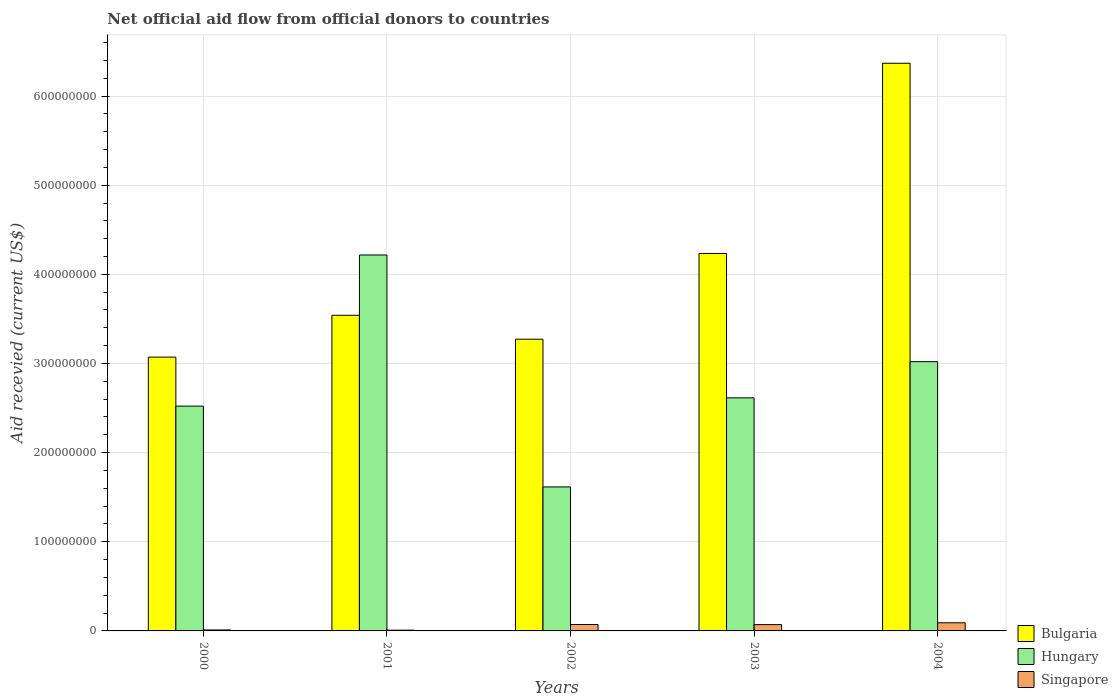How many different coloured bars are there?
Keep it short and to the point. 3. Are the number of bars per tick equal to the number of legend labels?
Your answer should be compact. Yes. What is the label of the 3rd group of bars from the left?
Your answer should be compact. 2002. In how many cases, is the number of bars for a given year not equal to the number of legend labels?
Your answer should be very brief. 0. What is the total aid received in Hungary in 2002?
Ensure brevity in your answer.  1.62e+08. Across all years, what is the maximum total aid received in Singapore?
Your answer should be compact. 9.14e+06. Across all years, what is the minimum total aid received in Bulgaria?
Your answer should be very brief. 3.07e+08. In which year was the total aid received in Hungary maximum?
Give a very brief answer. 2001. What is the total total aid received in Singapore in the graph?
Offer a terse response. 2.53e+07. What is the difference between the total aid received in Hungary in 2002 and that in 2003?
Your answer should be compact. -9.99e+07. What is the difference between the total aid received in Bulgaria in 2001 and the total aid received in Singapore in 2004?
Keep it short and to the point. 3.45e+08. What is the average total aid received in Hungary per year?
Ensure brevity in your answer.  2.80e+08. In the year 2002, what is the difference between the total aid received in Hungary and total aid received in Bulgaria?
Ensure brevity in your answer.  -1.66e+08. What is the ratio of the total aid received in Bulgaria in 2002 to that in 2004?
Give a very brief answer. 0.51. Is the total aid received in Hungary in 2002 less than that in 2003?
Provide a short and direct response. Yes. What is the difference between the highest and the second highest total aid received in Hungary?
Your answer should be very brief. 1.20e+08. What is the difference between the highest and the lowest total aid received in Singapore?
Your answer should be very brief. 8.29e+06. What does the 1st bar from the left in 2000 represents?
Keep it short and to the point. Bulgaria. What does the 2nd bar from the right in 2001 represents?
Offer a very short reply. Hungary. Is it the case that in every year, the sum of the total aid received in Bulgaria and total aid received in Hungary is greater than the total aid received in Singapore?
Make the answer very short. Yes. Are all the bars in the graph horizontal?
Provide a succinct answer. No. What is the difference between two consecutive major ticks on the Y-axis?
Give a very brief answer. 1.00e+08. Does the graph contain any zero values?
Give a very brief answer. No. Where does the legend appear in the graph?
Offer a terse response. Bottom right. What is the title of the graph?
Your answer should be very brief. Net official aid flow from official donors to countries. What is the label or title of the X-axis?
Provide a succinct answer. Years. What is the label or title of the Y-axis?
Provide a succinct answer. Aid recevied (current US$). What is the Aid recevied (current US$) in Bulgaria in 2000?
Provide a short and direct response. 3.07e+08. What is the Aid recevied (current US$) of Hungary in 2000?
Make the answer very short. 2.52e+08. What is the Aid recevied (current US$) of Singapore in 2000?
Make the answer very short. 1.09e+06. What is the Aid recevied (current US$) of Bulgaria in 2001?
Keep it short and to the point. 3.54e+08. What is the Aid recevied (current US$) of Hungary in 2001?
Your answer should be very brief. 4.22e+08. What is the Aid recevied (current US$) of Singapore in 2001?
Give a very brief answer. 8.50e+05. What is the Aid recevied (current US$) in Bulgaria in 2002?
Your answer should be very brief. 3.27e+08. What is the Aid recevied (current US$) of Hungary in 2002?
Make the answer very short. 1.62e+08. What is the Aid recevied (current US$) in Singapore in 2002?
Make the answer very short. 7.19e+06. What is the Aid recevied (current US$) of Bulgaria in 2003?
Keep it short and to the point. 4.23e+08. What is the Aid recevied (current US$) of Hungary in 2003?
Provide a short and direct response. 2.61e+08. What is the Aid recevied (current US$) of Singapore in 2003?
Your response must be concise. 7.07e+06. What is the Aid recevied (current US$) in Bulgaria in 2004?
Provide a short and direct response. 6.37e+08. What is the Aid recevied (current US$) of Hungary in 2004?
Your answer should be compact. 3.02e+08. What is the Aid recevied (current US$) of Singapore in 2004?
Make the answer very short. 9.14e+06. Across all years, what is the maximum Aid recevied (current US$) of Bulgaria?
Provide a short and direct response. 6.37e+08. Across all years, what is the maximum Aid recevied (current US$) in Hungary?
Your answer should be very brief. 4.22e+08. Across all years, what is the maximum Aid recevied (current US$) in Singapore?
Ensure brevity in your answer.  9.14e+06. Across all years, what is the minimum Aid recevied (current US$) of Bulgaria?
Give a very brief answer. 3.07e+08. Across all years, what is the minimum Aid recevied (current US$) of Hungary?
Keep it short and to the point. 1.62e+08. Across all years, what is the minimum Aid recevied (current US$) of Singapore?
Make the answer very short. 8.50e+05. What is the total Aid recevied (current US$) of Bulgaria in the graph?
Offer a very short reply. 2.05e+09. What is the total Aid recevied (current US$) in Hungary in the graph?
Provide a short and direct response. 1.40e+09. What is the total Aid recevied (current US$) of Singapore in the graph?
Offer a very short reply. 2.53e+07. What is the difference between the Aid recevied (current US$) of Bulgaria in 2000 and that in 2001?
Give a very brief answer. -4.69e+07. What is the difference between the Aid recevied (current US$) of Hungary in 2000 and that in 2001?
Ensure brevity in your answer.  -1.70e+08. What is the difference between the Aid recevied (current US$) of Singapore in 2000 and that in 2001?
Your response must be concise. 2.40e+05. What is the difference between the Aid recevied (current US$) of Bulgaria in 2000 and that in 2002?
Ensure brevity in your answer.  -2.01e+07. What is the difference between the Aid recevied (current US$) in Hungary in 2000 and that in 2002?
Your answer should be compact. 9.06e+07. What is the difference between the Aid recevied (current US$) of Singapore in 2000 and that in 2002?
Offer a terse response. -6.10e+06. What is the difference between the Aid recevied (current US$) in Bulgaria in 2000 and that in 2003?
Your answer should be very brief. -1.16e+08. What is the difference between the Aid recevied (current US$) of Hungary in 2000 and that in 2003?
Provide a succinct answer. -9.28e+06. What is the difference between the Aid recevied (current US$) of Singapore in 2000 and that in 2003?
Provide a short and direct response. -5.98e+06. What is the difference between the Aid recevied (current US$) in Bulgaria in 2000 and that in 2004?
Give a very brief answer. -3.30e+08. What is the difference between the Aid recevied (current US$) in Hungary in 2000 and that in 2004?
Ensure brevity in your answer.  -4.98e+07. What is the difference between the Aid recevied (current US$) in Singapore in 2000 and that in 2004?
Offer a terse response. -8.05e+06. What is the difference between the Aid recevied (current US$) of Bulgaria in 2001 and that in 2002?
Offer a terse response. 2.68e+07. What is the difference between the Aid recevied (current US$) of Hungary in 2001 and that in 2002?
Provide a succinct answer. 2.60e+08. What is the difference between the Aid recevied (current US$) in Singapore in 2001 and that in 2002?
Your response must be concise. -6.34e+06. What is the difference between the Aid recevied (current US$) in Bulgaria in 2001 and that in 2003?
Give a very brief answer. -6.94e+07. What is the difference between the Aid recevied (current US$) in Hungary in 2001 and that in 2003?
Your answer should be compact. 1.60e+08. What is the difference between the Aid recevied (current US$) in Singapore in 2001 and that in 2003?
Your answer should be compact. -6.22e+06. What is the difference between the Aid recevied (current US$) in Bulgaria in 2001 and that in 2004?
Ensure brevity in your answer.  -2.83e+08. What is the difference between the Aid recevied (current US$) of Hungary in 2001 and that in 2004?
Provide a short and direct response. 1.20e+08. What is the difference between the Aid recevied (current US$) of Singapore in 2001 and that in 2004?
Your answer should be compact. -8.29e+06. What is the difference between the Aid recevied (current US$) of Bulgaria in 2002 and that in 2003?
Your answer should be compact. -9.62e+07. What is the difference between the Aid recevied (current US$) in Hungary in 2002 and that in 2003?
Keep it short and to the point. -9.99e+07. What is the difference between the Aid recevied (current US$) of Bulgaria in 2002 and that in 2004?
Provide a succinct answer. -3.10e+08. What is the difference between the Aid recevied (current US$) in Hungary in 2002 and that in 2004?
Your answer should be compact. -1.40e+08. What is the difference between the Aid recevied (current US$) of Singapore in 2002 and that in 2004?
Give a very brief answer. -1.95e+06. What is the difference between the Aid recevied (current US$) of Bulgaria in 2003 and that in 2004?
Provide a short and direct response. -2.13e+08. What is the difference between the Aid recevied (current US$) of Hungary in 2003 and that in 2004?
Make the answer very short. -4.06e+07. What is the difference between the Aid recevied (current US$) of Singapore in 2003 and that in 2004?
Offer a terse response. -2.07e+06. What is the difference between the Aid recevied (current US$) in Bulgaria in 2000 and the Aid recevied (current US$) in Hungary in 2001?
Offer a terse response. -1.15e+08. What is the difference between the Aid recevied (current US$) of Bulgaria in 2000 and the Aid recevied (current US$) of Singapore in 2001?
Give a very brief answer. 3.06e+08. What is the difference between the Aid recevied (current US$) in Hungary in 2000 and the Aid recevied (current US$) in Singapore in 2001?
Your response must be concise. 2.51e+08. What is the difference between the Aid recevied (current US$) of Bulgaria in 2000 and the Aid recevied (current US$) of Hungary in 2002?
Your response must be concise. 1.46e+08. What is the difference between the Aid recevied (current US$) of Bulgaria in 2000 and the Aid recevied (current US$) of Singapore in 2002?
Provide a succinct answer. 3.00e+08. What is the difference between the Aid recevied (current US$) in Hungary in 2000 and the Aid recevied (current US$) in Singapore in 2002?
Offer a terse response. 2.45e+08. What is the difference between the Aid recevied (current US$) in Bulgaria in 2000 and the Aid recevied (current US$) in Hungary in 2003?
Ensure brevity in your answer.  4.57e+07. What is the difference between the Aid recevied (current US$) in Bulgaria in 2000 and the Aid recevied (current US$) in Singapore in 2003?
Your answer should be compact. 3.00e+08. What is the difference between the Aid recevied (current US$) of Hungary in 2000 and the Aid recevied (current US$) of Singapore in 2003?
Make the answer very short. 2.45e+08. What is the difference between the Aid recevied (current US$) in Bulgaria in 2000 and the Aid recevied (current US$) in Hungary in 2004?
Offer a very short reply. 5.13e+06. What is the difference between the Aid recevied (current US$) in Bulgaria in 2000 and the Aid recevied (current US$) in Singapore in 2004?
Your response must be concise. 2.98e+08. What is the difference between the Aid recevied (current US$) of Hungary in 2000 and the Aid recevied (current US$) of Singapore in 2004?
Your response must be concise. 2.43e+08. What is the difference between the Aid recevied (current US$) in Bulgaria in 2001 and the Aid recevied (current US$) in Hungary in 2002?
Provide a succinct answer. 1.93e+08. What is the difference between the Aid recevied (current US$) in Bulgaria in 2001 and the Aid recevied (current US$) in Singapore in 2002?
Give a very brief answer. 3.47e+08. What is the difference between the Aid recevied (current US$) in Hungary in 2001 and the Aid recevied (current US$) in Singapore in 2002?
Give a very brief answer. 4.14e+08. What is the difference between the Aid recevied (current US$) of Bulgaria in 2001 and the Aid recevied (current US$) of Hungary in 2003?
Your answer should be compact. 9.26e+07. What is the difference between the Aid recevied (current US$) of Bulgaria in 2001 and the Aid recevied (current US$) of Singapore in 2003?
Provide a short and direct response. 3.47e+08. What is the difference between the Aid recevied (current US$) in Hungary in 2001 and the Aid recevied (current US$) in Singapore in 2003?
Provide a short and direct response. 4.15e+08. What is the difference between the Aid recevied (current US$) in Bulgaria in 2001 and the Aid recevied (current US$) in Hungary in 2004?
Offer a terse response. 5.20e+07. What is the difference between the Aid recevied (current US$) in Bulgaria in 2001 and the Aid recevied (current US$) in Singapore in 2004?
Provide a succinct answer. 3.45e+08. What is the difference between the Aid recevied (current US$) in Hungary in 2001 and the Aid recevied (current US$) in Singapore in 2004?
Keep it short and to the point. 4.13e+08. What is the difference between the Aid recevied (current US$) of Bulgaria in 2002 and the Aid recevied (current US$) of Hungary in 2003?
Make the answer very short. 6.58e+07. What is the difference between the Aid recevied (current US$) of Bulgaria in 2002 and the Aid recevied (current US$) of Singapore in 2003?
Make the answer very short. 3.20e+08. What is the difference between the Aid recevied (current US$) in Hungary in 2002 and the Aid recevied (current US$) in Singapore in 2003?
Your answer should be very brief. 1.54e+08. What is the difference between the Aid recevied (current US$) of Bulgaria in 2002 and the Aid recevied (current US$) of Hungary in 2004?
Offer a very short reply. 2.52e+07. What is the difference between the Aid recevied (current US$) of Bulgaria in 2002 and the Aid recevied (current US$) of Singapore in 2004?
Make the answer very short. 3.18e+08. What is the difference between the Aid recevied (current US$) of Hungary in 2002 and the Aid recevied (current US$) of Singapore in 2004?
Provide a short and direct response. 1.52e+08. What is the difference between the Aid recevied (current US$) of Bulgaria in 2003 and the Aid recevied (current US$) of Hungary in 2004?
Make the answer very short. 1.21e+08. What is the difference between the Aid recevied (current US$) in Bulgaria in 2003 and the Aid recevied (current US$) in Singapore in 2004?
Make the answer very short. 4.14e+08. What is the difference between the Aid recevied (current US$) in Hungary in 2003 and the Aid recevied (current US$) in Singapore in 2004?
Your answer should be very brief. 2.52e+08. What is the average Aid recevied (current US$) in Bulgaria per year?
Keep it short and to the point. 4.10e+08. What is the average Aid recevied (current US$) in Hungary per year?
Keep it short and to the point. 2.80e+08. What is the average Aid recevied (current US$) in Singapore per year?
Ensure brevity in your answer.  5.07e+06. In the year 2000, what is the difference between the Aid recevied (current US$) of Bulgaria and Aid recevied (current US$) of Hungary?
Your response must be concise. 5.50e+07. In the year 2000, what is the difference between the Aid recevied (current US$) in Bulgaria and Aid recevied (current US$) in Singapore?
Provide a succinct answer. 3.06e+08. In the year 2000, what is the difference between the Aid recevied (current US$) of Hungary and Aid recevied (current US$) of Singapore?
Provide a short and direct response. 2.51e+08. In the year 2001, what is the difference between the Aid recevied (current US$) in Bulgaria and Aid recevied (current US$) in Hungary?
Provide a short and direct response. -6.76e+07. In the year 2001, what is the difference between the Aid recevied (current US$) of Bulgaria and Aid recevied (current US$) of Singapore?
Give a very brief answer. 3.53e+08. In the year 2001, what is the difference between the Aid recevied (current US$) in Hungary and Aid recevied (current US$) in Singapore?
Make the answer very short. 4.21e+08. In the year 2002, what is the difference between the Aid recevied (current US$) in Bulgaria and Aid recevied (current US$) in Hungary?
Ensure brevity in your answer.  1.66e+08. In the year 2002, what is the difference between the Aid recevied (current US$) of Bulgaria and Aid recevied (current US$) of Singapore?
Your answer should be compact. 3.20e+08. In the year 2002, what is the difference between the Aid recevied (current US$) of Hungary and Aid recevied (current US$) of Singapore?
Give a very brief answer. 1.54e+08. In the year 2003, what is the difference between the Aid recevied (current US$) in Bulgaria and Aid recevied (current US$) in Hungary?
Ensure brevity in your answer.  1.62e+08. In the year 2003, what is the difference between the Aid recevied (current US$) in Bulgaria and Aid recevied (current US$) in Singapore?
Ensure brevity in your answer.  4.16e+08. In the year 2003, what is the difference between the Aid recevied (current US$) in Hungary and Aid recevied (current US$) in Singapore?
Make the answer very short. 2.54e+08. In the year 2004, what is the difference between the Aid recevied (current US$) in Bulgaria and Aid recevied (current US$) in Hungary?
Ensure brevity in your answer.  3.35e+08. In the year 2004, what is the difference between the Aid recevied (current US$) of Bulgaria and Aid recevied (current US$) of Singapore?
Provide a succinct answer. 6.28e+08. In the year 2004, what is the difference between the Aid recevied (current US$) in Hungary and Aid recevied (current US$) in Singapore?
Your answer should be compact. 2.93e+08. What is the ratio of the Aid recevied (current US$) of Bulgaria in 2000 to that in 2001?
Make the answer very short. 0.87. What is the ratio of the Aid recevied (current US$) of Hungary in 2000 to that in 2001?
Ensure brevity in your answer.  0.6. What is the ratio of the Aid recevied (current US$) of Singapore in 2000 to that in 2001?
Make the answer very short. 1.28. What is the ratio of the Aid recevied (current US$) of Bulgaria in 2000 to that in 2002?
Give a very brief answer. 0.94. What is the ratio of the Aid recevied (current US$) of Hungary in 2000 to that in 2002?
Give a very brief answer. 1.56. What is the ratio of the Aid recevied (current US$) of Singapore in 2000 to that in 2002?
Your answer should be very brief. 0.15. What is the ratio of the Aid recevied (current US$) in Bulgaria in 2000 to that in 2003?
Offer a very short reply. 0.73. What is the ratio of the Aid recevied (current US$) of Hungary in 2000 to that in 2003?
Provide a succinct answer. 0.96. What is the ratio of the Aid recevied (current US$) of Singapore in 2000 to that in 2003?
Make the answer very short. 0.15. What is the ratio of the Aid recevied (current US$) in Bulgaria in 2000 to that in 2004?
Provide a short and direct response. 0.48. What is the ratio of the Aid recevied (current US$) of Hungary in 2000 to that in 2004?
Offer a terse response. 0.83. What is the ratio of the Aid recevied (current US$) of Singapore in 2000 to that in 2004?
Give a very brief answer. 0.12. What is the ratio of the Aid recevied (current US$) of Bulgaria in 2001 to that in 2002?
Ensure brevity in your answer.  1.08. What is the ratio of the Aid recevied (current US$) of Hungary in 2001 to that in 2002?
Your answer should be very brief. 2.61. What is the ratio of the Aid recevied (current US$) in Singapore in 2001 to that in 2002?
Make the answer very short. 0.12. What is the ratio of the Aid recevied (current US$) of Bulgaria in 2001 to that in 2003?
Your answer should be very brief. 0.84. What is the ratio of the Aid recevied (current US$) of Hungary in 2001 to that in 2003?
Give a very brief answer. 1.61. What is the ratio of the Aid recevied (current US$) in Singapore in 2001 to that in 2003?
Make the answer very short. 0.12. What is the ratio of the Aid recevied (current US$) in Bulgaria in 2001 to that in 2004?
Offer a very short reply. 0.56. What is the ratio of the Aid recevied (current US$) in Hungary in 2001 to that in 2004?
Make the answer very short. 1.4. What is the ratio of the Aid recevied (current US$) of Singapore in 2001 to that in 2004?
Ensure brevity in your answer.  0.09. What is the ratio of the Aid recevied (current US$) of Bulgaria in 2002 to that in 2003?
Give a very brief answer. 0.77. What is the ratio of the Aid recevied (current US$) of Hungary in 2002 to that in 2003?
Your answer should be very brief. 0.62. What is the ratio of the Aid recevied (current US$) of Bulgaria in 2002 to that in 2004?
Your response must be concise. 0.51. What is the ratio of the Aid recevied (current US$) in Hungary in 2002 to that in 2004?
Provide a succinct answer. 0.53. What is the ratio of the Aid recevied (current US$) in Singapore in 2002 to that in 2004?
Offer a very short reply. 0.79. What is the ratio of the Aid recevied (current US$) of Bulgaria in 2003 to that in 2004?
Provide a succinct answer. 0.67. What is the ratio of the Aid recevied (current US$) of Hungary in 2003 to that in 2004?
Make the answer very short. 0.87. What is the ratio of the Aid recevied (current US$) in Singapore in 2003 to that in 2004?
Offer a terse response. 0.77. What is the difference between the highest and the second highest Aid recevied (current US$) of Bulgaria?
Make the answer very short. 2.13e+08. What is the difference between the highest and the second highest Aid recevied (current US$) of Hungary?
Provide a short and direct response. 1.20e+08. What is the difference between the highest and the second highest Aid recevied (current US$) in Singapore?
Keep it short and to the point. 1.95e+06. What is the difference between the highest and the lowest Aid recevied (current US$) in Bulgaria?
Offer a terse response. 3.30e+08. What is the difference between the highest and the lowest Aid recevied (current US$) of Hungary?
Offer a very short reply. 2.60e+08. What is the difference between the highest and the lowest Aid recevied (current US$) in Singapore?
Keep it short and to the point. 8.29e+06. 